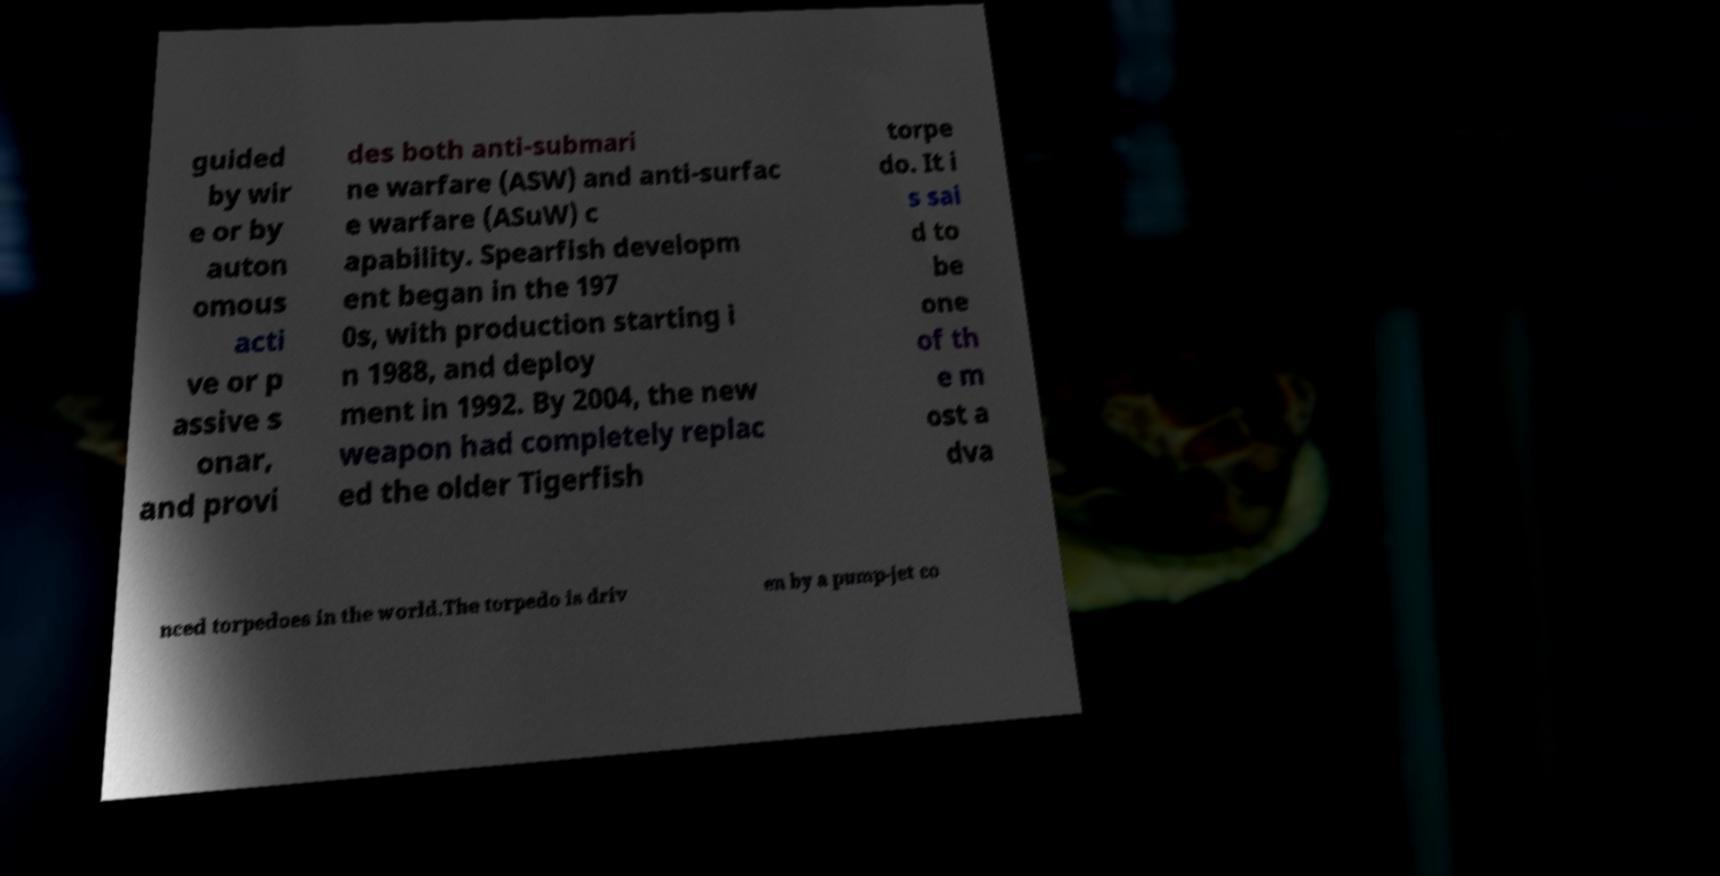I need the written content from this picture converted into text. Can you do that? guided by wir e or by auton omous acti ve or p assive s onar, and provi des both anti-submari ne warfare (ASW) and anti-surfac e warfare (ASuW) c apability. Spearfish developm ent began in the 197 0s, with production starting i n 1988, and deploy ment in 1992. By 2004, the new weapon had completely replac ed the older Tigerfish torpe do. It i s sai d to be one of th e m ost a dva nced torpedoes in the world.The torpedo is driv en by a pump-jet co 